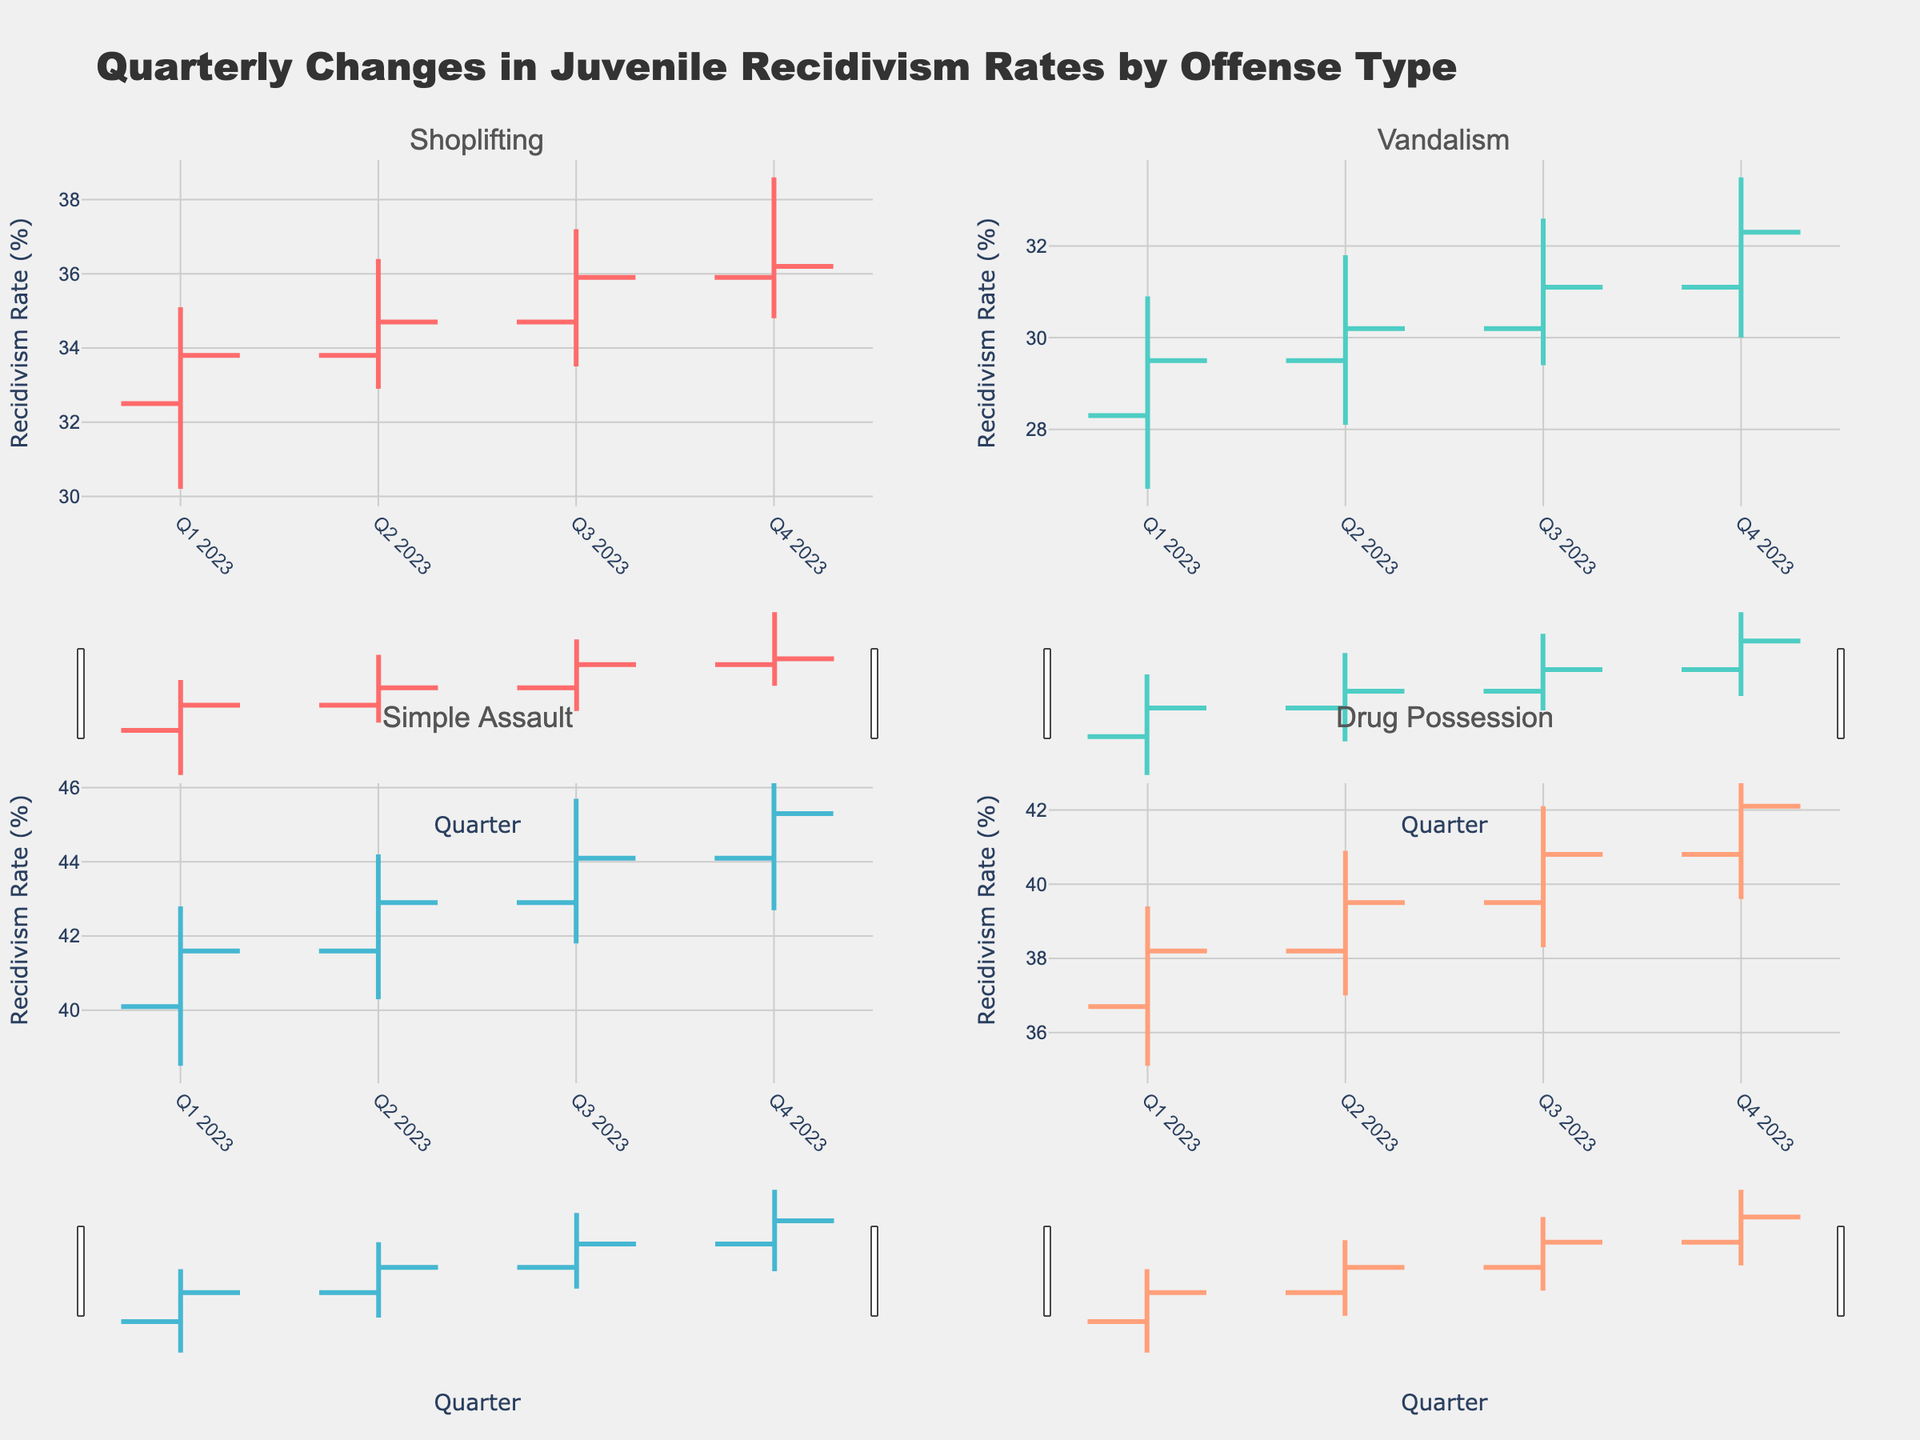What is the title of the figure? The title is located at the top of the figure, and it provides an overview of what the plot represents. It reads "Quarterly Changes in Juvenile Recidivism Rates by Offense Type".
Answer: Quarterly Changes in Juvenile Recidivism Rates by Offense Type How many different offenses are shown in the figure? The figure includes subplots for each type of offense with a title for each subplot. By counting these titles, we can determine the number of different offenses. There are four titles: Shoplifting, Vandalism, Simple Assault, and Drug Possession.
Answer: 4 Which offense had the highest recidivism rate in Q4 2023? Look at each subplot and check the highest 'High' value for Q4 2023. Simple Assault has the highest 'High' value of 46.9.
Answer: Simple Assault What was the recidivism rate for Shoplifting at the close of Q1 2023? In the subplot for Shoplifting, find the 'Close' value for Q1 2023. It is 33.8.
Answer: 33.8 Which offense experienced the largest increase in recidivism rate from Q1 to Q4 2023? For each offense, subtract the 'Open' value of Q1 from the 'Close' value of Q4. The calculation is as follows:
- Shoplifting: 36.2 - 32.5 = 3.7
- Vandalism: 32.3 - 28.3 = 4.0
- Simple Assault: 45.3 - 40.1 = 5.2
- Drug Possession: 42.1 - 36.7 = 5.4
Drug Possession has the largest increase.
Answer: Drug Possession What was the low recidivism rate for Vandalism in Q3 2023? In the subplot for Vandalism, look for the 'Low' value for Q3 2023, which is 29.4.
Answer: 29.4 Between which pairs of consecutive quarters did the recidivism rate for Simple Assault increase the most? Calculate the difference between the 'Close' values of consecutive quarters for Simple Assault:
- Q1 to Q2: 42.9 - 41.6 = 1.3
- Q2 to Q3: 44.1 - 42.9 = 1.2
- Q3 to Q4: 45.3 - 44.1 = 1.2
The largest increase is from Q1 to Q2.
Answer: Q1 to Q2 Which offense had the least variation in recidivism rates in Q2 2023? Variation can be approximated by the range (High - Low) for each offense in Q2 2023:
- Shoplifting: 36.4 - 32.9 = 3.5
- Vandalism: 31.8 - 28.1 = 3.7
- Simple Assault: 44.2 - 40.3 = 3.9
- Drug Possession: 40.9 - 37.0 = 3.9
Shoplifting had the least variation.
Answer: Shoplifting What trend do you observe about the recidivism rates for Drug Possession over the four quarters of 2023? Looking at the subplot for Drug Possession, observe the 'Close' values over the four quarters: 38.2, 39.5, 40.8, and 42.1. The recidivism rates steadily increase each quarter.
Answer: Steady increase 